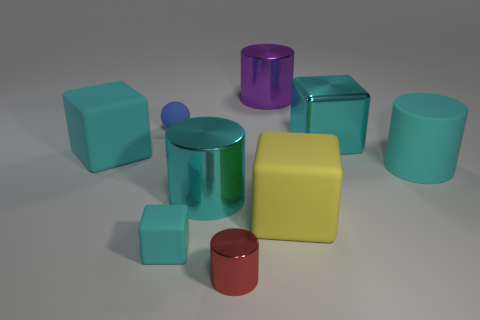Subtract all blue cylinders. How many cyan blocks are left? 3 Subtract 1 blocks. How many blocks are left? 3 Add 1 cyan cylinders. How many objects exist? 10 Subtract all cylinders. How many objects are left? 5 Add 6 big purple metal cylinders. How many big purple metal cylinders are left? 7 Add 6 cyan shiny cubes. How many cyan shiny cubes exist? 7 Subtract 1 yellow cubes. How many objects are left? 8 Subtract all red metal things. Subtract all big matte cylinders. How many objects are left? 7 